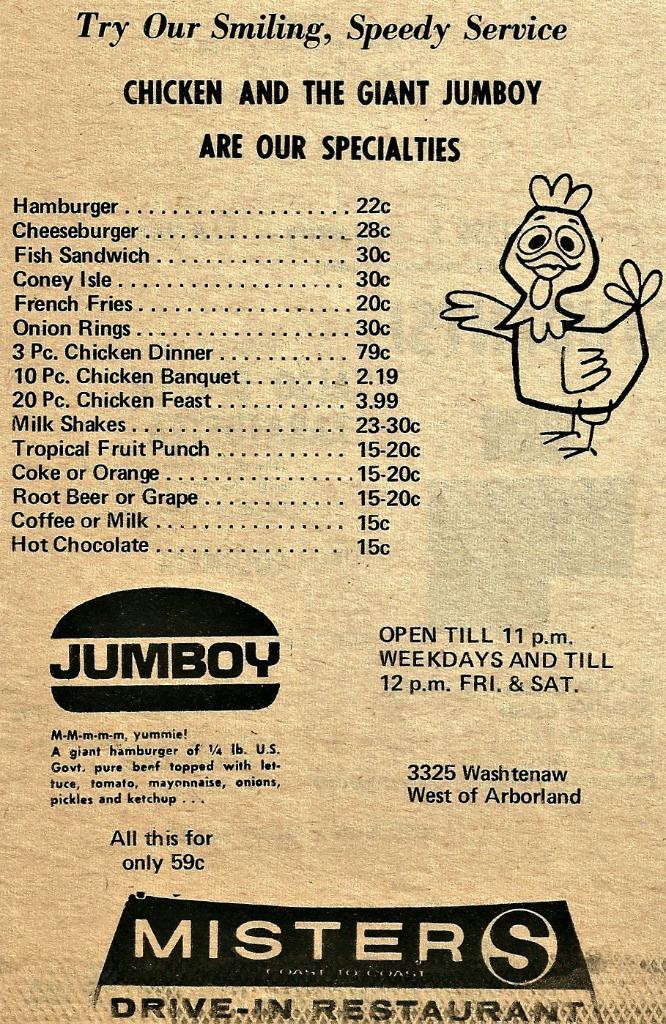What type of restaurant?
Your answer should be very brief. Drive-in. 